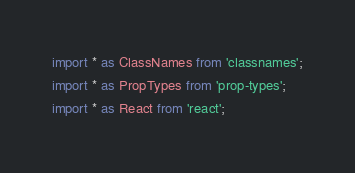<code> <loc_0><loc_0><loc_500><loc_500><_TypeScript_>import * as ClassNames from 'classnames';
import * as PropTypes from 'prop-types';
import * as React from 'react';</code> 